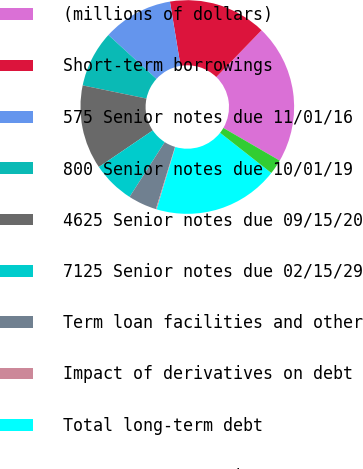<chart> <loc_0><loc_0><loc_500><loc_500><pie_chart><fcel>(millions of dollars)<fcel>Short-term borrowings<fcel>575 Senior notes due 11/01/16<fcel>800 Senior notes due 10/01/19<fcel>4625 Senior notes due 09/15/20<fcel>7125 Senior notes due 02/15/29<fcel>Term loan facilities and other<fcel>Impact of derivatives on debt<fcel>Total long-term debt<fcel>Less current portion<nl><fcel>21.13%<fcel>14.83%<fcel>10.63%<fcel>8.53%<fcel>12.73%<fcel>6.43%<fcel>4.33%<fcel>0.13%<fcel>19.03%<fcel>2.23%<nl></chart> 